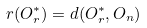<formula> <loc_0><loc_0><loc_500><loc_500>r ( O _ { r } ^ { * } ) = d ( O _ { r } ^ { * } , O _ { n } )</formula> 